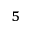Convert formula to latex. <formula><loc_0><loc_0><loc_500><loc_500>_ { 5 }</formula> 